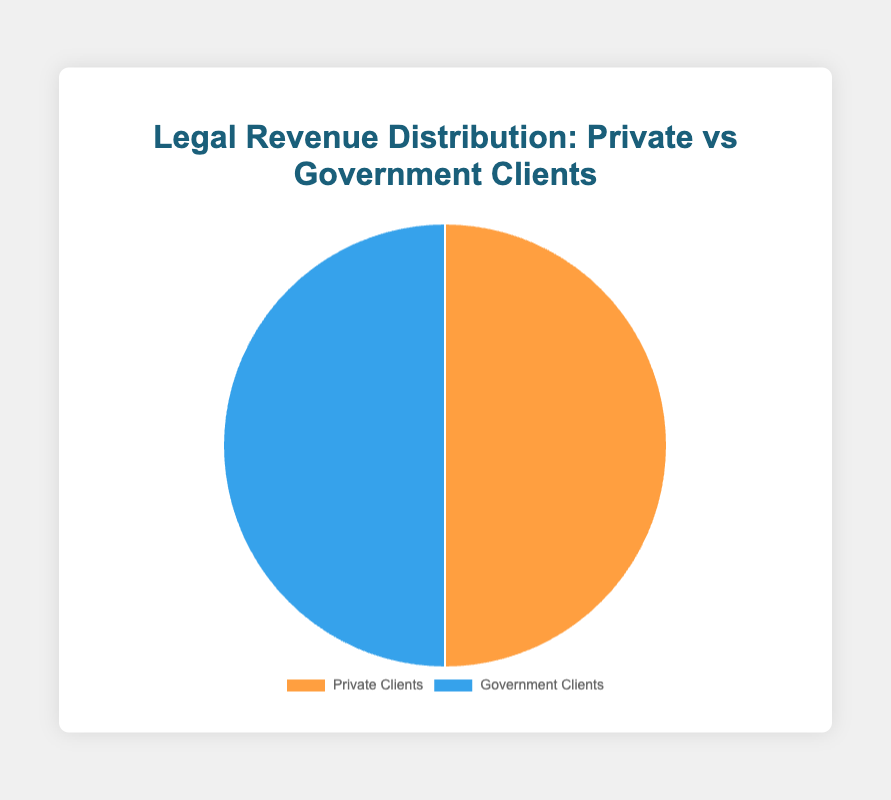Which type of client generates more revenue, private or government? According to the pie chart, both private and government clients contribute equally to the legal revenue distribution. Each section of the pie chart represents 50% for private clients and 50% for government clients.
Answer: Both contribute equally Is the revenue from Tata Consultancy Services greater than the revenue from the Ministry of Finance? From the given data, Tata Consultancy Services contributes 40% of the private client revenue, and the Ministry of Finance contributes 25% of the government client revenue.
Answer: Yes What is the combined revenue percentage from Reliance Industries and the Ministry of Finance? Reliance Industries contributes 25% and the Ministry of Finance contributes 25%. Adding these percentages gives a total combined revenue of 25% + 25% = 50%.
Answer: 50% Which sector has a more diverse distribution of clients, private or government? The private client sector has a more diverse distribution as it has 6 different clients compared to the government sector which has 5 clients.
Answer: Private Clients Which client contributes the least to the total revenue? Both Wipro and HDFC Bank from private clients and the Ministry of Law and Justice from government clients each contribute 5%.
Answer: Wipro, HDFC Bank, and Ministry of Law and Justice How does the total revenue from Infosys compare to the total revenue from the Ministry of Defence? Infosys contributes 15% to private client revenue, while the Ministry of Defence contributes 20% to government client revenue. Therefore, the Ministry of Defence's contribution is higher.
Answer: Ministry of Defence contributes more Explain the difference in revenue contribution between Adani Group and Ministry of Home Affairs. Adani Group contributes 10% to private client revenue and Ministry of Home Affairs contributes 10% to government client revenue. Thus, the contributions are equal.
Answer: They are equal If the contributions of Tata Consultancy Services and Ministry of Corporate Affairs were combined, what would their total share be? Tata Consultancy Services contributes 40% and the Ministry of Corporate Affairs contributes 40%. Combining these would be 40% + 40% = 80%.
Answer: 80% What is the total combined revenue percentage from all clients in each sector? The total combined revenue percentage for private clients and government clients each adds up to 100% since they represent separate users of the pie chart. Both private and government sectors equally represent the chart's revenue.
Answer: 100% for both 